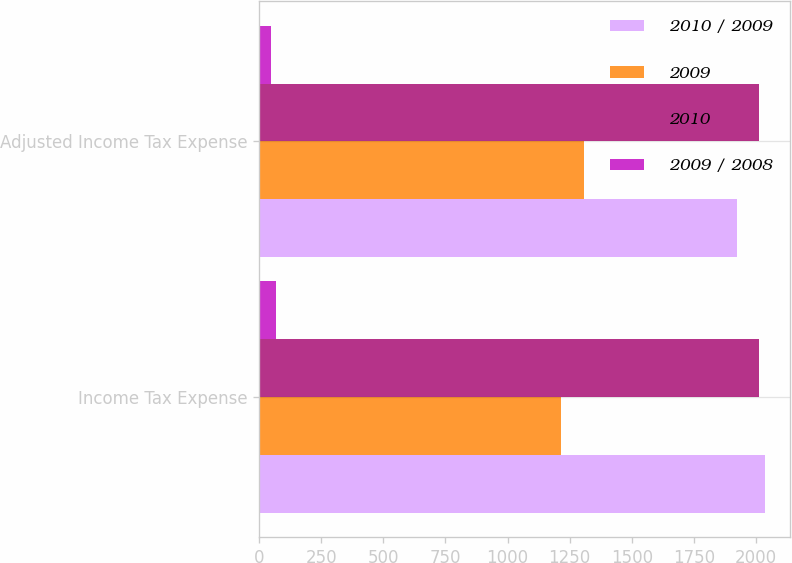Convert chart to OTSL. <chart><loc_0><loc_0><loc_500><loc_500><stacked_bar_chart><ecel><fcel>Income Tax Expense<fcel>Adjusted Income Tax Expense<nl><fcel>2010 / 2009<fcel>2035<fcel>1922<nl><fcel>2009<fcel>1214<fcel>1308<nl><fcel>2010<fcel>2012<fcel>2012<nl><fcel>2009 / 2008<fcel>67.6<fcel>46.9<nl></chart> 